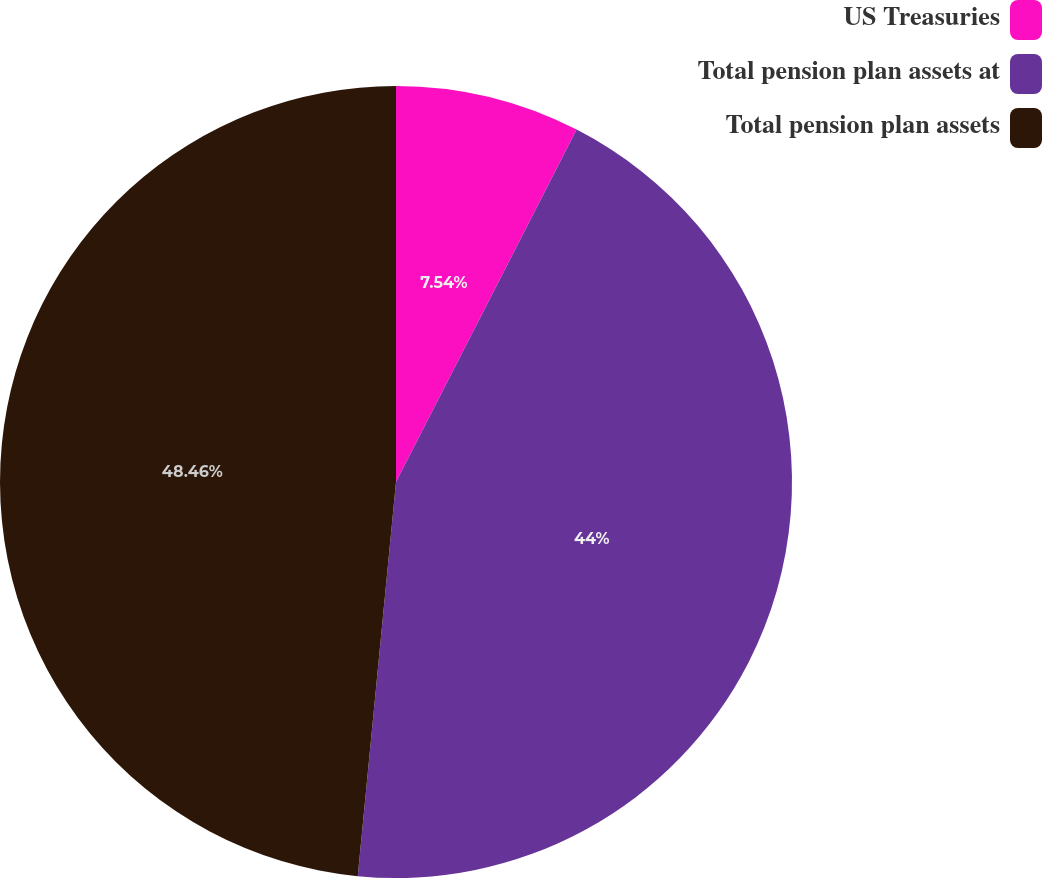Convert chart to OTSL. <chart><loc_0><loc_0><loc_500><loc_500><pie_chart><fcel>US Treasuries<fcel>Total pension plan assets at<fcel>Total pension plan assets<nl><fcel>7.54%<fcel>44.0%<fcel>48.46%<nl></chart> 